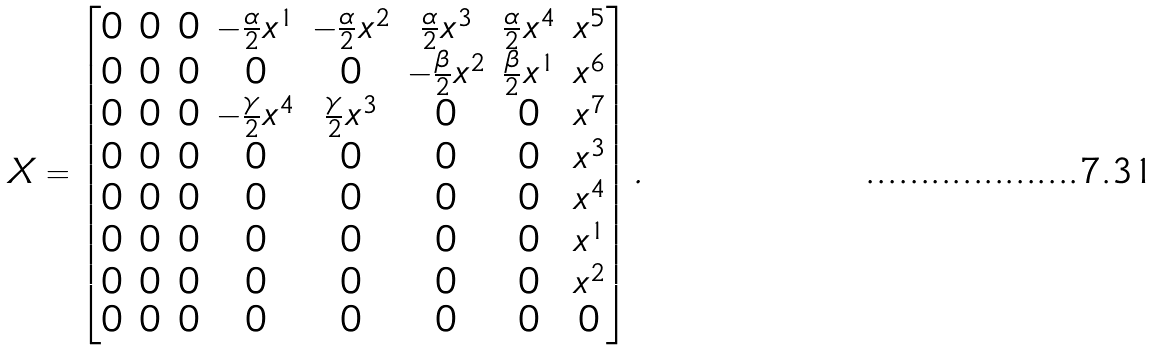<formula> <loc_0><loc_0><loc_500><loc_500>X = \begin{bmatrix} 0 & 0 & 0 & - \frac { \alpha } { 2 } x ^ { 1 } & - \frac { \alpha } { 2 } x ^ { 2 } & \frac { \alpha } { 2 } x ^ { 3 } & \frac { \alpha } { 2 } x ^ { 4 } & x ^ { 5 } \\ 0 & 0 & 0 & 0 & 0 & - \frac { \beta } { 2 } x ^ { 2 } & \frac { \beta } { 2 } x ^ { 1 } & x ^ { 6 } \\ 0 & 0 & 0 & - \frac { \gamma } { 2 } x ^ { 4 } & \frac { \gamma } { 2 } x ^ { 3 } & 0 & 0 & x ^ { 7 } \\ 0 & 0 & 0 & 0 & 0 & 0 & 0 & x ^ { 3 } \\ 0 & 0 & 0 & 0 & 0 & 0 & 0 & x ^ { 4 } \\ 0 & 0 & 0 & 0 & 0 & 0 & 0 & x ^ { 1 } \\ 0 & 0 & 0 & 0 & 0 & 0 & 0 & x ^ { 2 } \\ 0 & 0 & 0 & 0 & 0 & 0 & 0 & 0 \end{bmatrix} .</formula> 